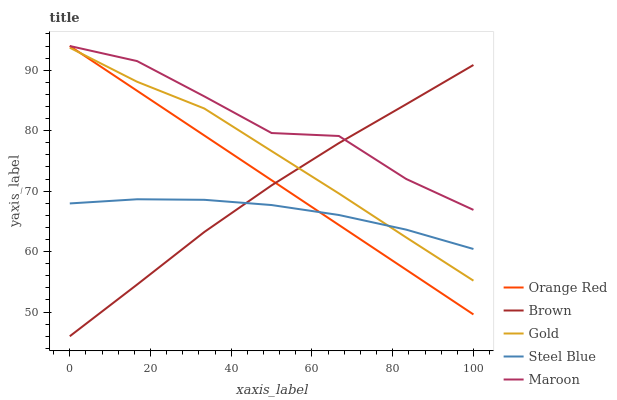Does Steel Blue have the minimum area under the curve?
Answer yes or no. Yes. Does Maroon have the maximum area under the curve?
Answer yes or no. Yes. Does Brown have the minimum area under the curve?
Answer yes or no. No. Does Brown have the maximum area under the curve?
Answer yes or no. No. Is Orange Red the smoothest?
Answer yes or no. Yes. Is Maroon the roughest?
Answer yes or no. Yes. Is Brown the smoothest?
Answer yes or no. No. Is Brown the roughest?
Answer yes or no. No. Does Brown have the lowest value?
Answer yes or no. Yes. Does Orange Red have the lowest value?
Answer yes or no. No. Does Orange Red have the highest value?
Answer yes or no. Yes. Does Brown have the highest value?
Answer yes or no. No. Is Steel Blue less than Maroon?
Answer yes or no. Yes. Is Maroon greater than Steel Blue?
Answer yes or no. Yes. Does Steel Blue intersect Orange Red?
Answer yes or no. Yes. Is Steel Blue less than Orange Red?
Answer yes or no. No. Is Steel Blue greater than Orange Red?
Answer yes or no. No. Does Steel Blue intersect Maroon?
Answer yes or no. No. 